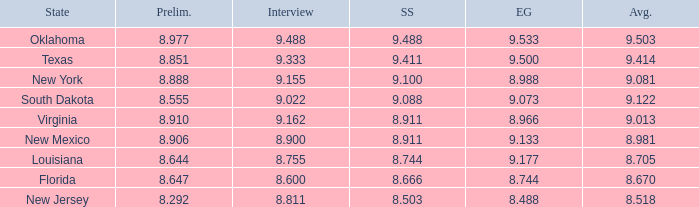Could you help me parse every detail presented in this table? {'header': ['State', 'Prelim.', 'Interview', 'SS', 'EG', 'Avg.'], 'rows': [['Oklahoma', '8.977', '9.488', '9.488', '9.533', '9.503'], ['Texas', '8.851', '9.333', '9.411', '9.500', '9.414'], ['New York', '8.888', '9.155', '9.100', '8.988', '9.081'], ['South Dakota', '8.555', '9.022', '9.088', '9.073', '9.122'], ['Virginia', '8.910', '9.162', '8.911', '8.966', '9.013'], ['New Mexico', '8.906', '8.900', '8.911', '9.133', '8.981'], ['Louisiana', '8.644', '8.755', '8.744', '9.177', '8.705'], ['Florida', '8.647', '8.600', '8.666', '8.744', '8.670'], ['New Jersey', '8.292', '8.811', '8.503', '8.488', '8.518']]}  what's the evening gown where state is south dakota 9.073. 